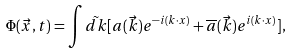<formula> <loc_0><loc_0><loc_500><loc_500>\Phi ( \vec { x } , t ) = \int \tilde { d k } [ a ( \vec { k } ) e ^ { - i ( k \cdot x ) } + { \overline { a } } ( \vec { k } ) e ^ { i ( k \cdot x ) } ] ,</formula> 